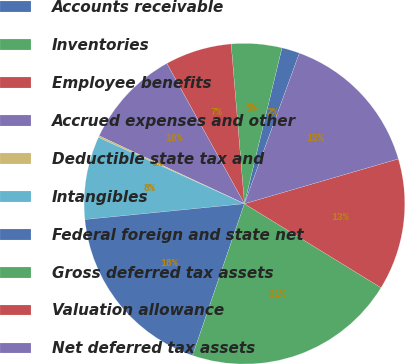Convert chart to OTSL. <chart><loc_0><loc_0><loc_500><loc_500><pie_chart><fcel>Accounts receivable<fcel>Inventories<fcel>Employee benefits<fcel>Accrued expenses and other<fcel>Deductible state tax and<fcel>Intangibles<fcel>Federal foreign and state net<fcel>Gross deferred tax assets<fcel>Valuation allowance<fcel>Net deferred tax assets<nl><fcel>1.81%<fcel>5.08%<fcel>6.72%<fcel>10.0%<fcel>0.17%<fcel>8.36%<fcel>18.19%<fcel>21.47%<fcel>13.28%<fcel>14.92%<nl></chart> 